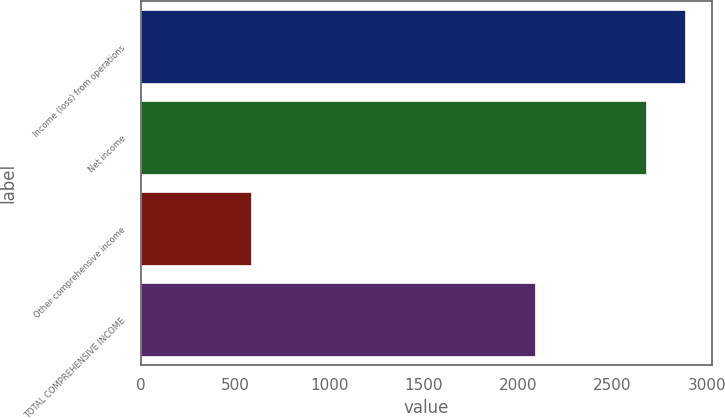Convert chart to OTSL. <chart><loc_0><loc_0><loc_500><loc_500><bar_chart><fcel>Income (loss) from operations<fcel>Net income<fcel>Other comprehensive income<fcel>TOTAL COMPREHENSIVE INCOME<nl><fcel>2884.9<fcel>2675<fcel>587<fcel>2088<nl></chart> 